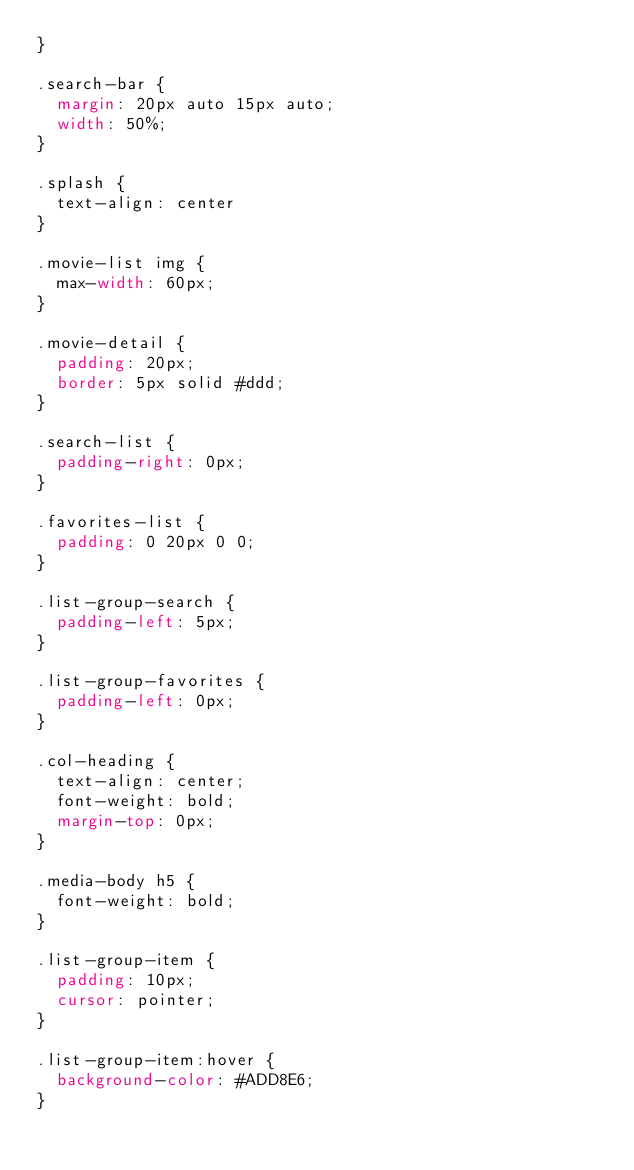<code> <loc_0><loc_0><loc_500><loc_500><_CSS_>}

.search-bar {
  margin: 20px auto 15px auto;
  width: 50%;
}

.splash {
  text-align: center
}

.movie-list img {
  max-width: 60px;
}

.movie-detail {
  padding: 20px;
  border: 5px solid #ddd;
}

.search-list {
  padding-right: 0px;
}

.favorites-list {
  padding: 0 20px 0 0;
}

.list-group-search {
  padding-left: 5px;
}

.list-group-favorites {
  padding-left: 0px;
}

.col-heading {
  text-align: center;
  font-weight: bold;
  margin-top: 0px;
}

.media-body h5 {
  font-weight: bold;
}

.list-group-item {
  padding: 10px;
  cursor: pointer;
}

.list-group-item:hover {
  background-color: #ADD8E6;
}
</code> 